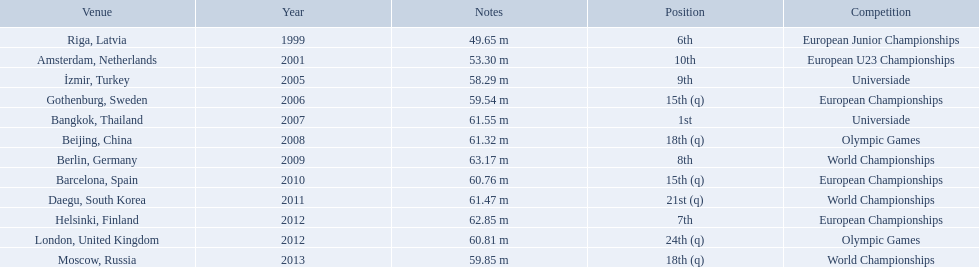What european junior championships? 6th. What waseuropean junior championships best result? 63.17 m. 